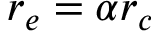Convert formula to latex. <formula><loc_0><loc_0><loc_500><loc_500>r _ { e } = \alpha r _ { c }</formula> 